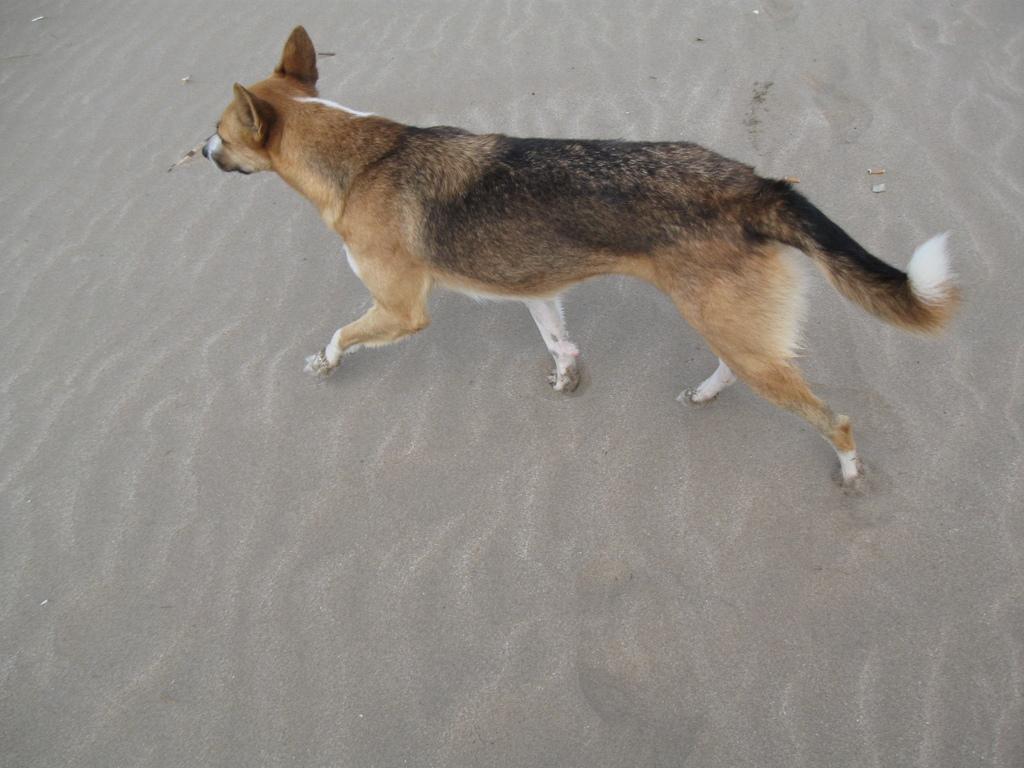Can you describe this image briefly? In this image there is a dog walking on the sand. 